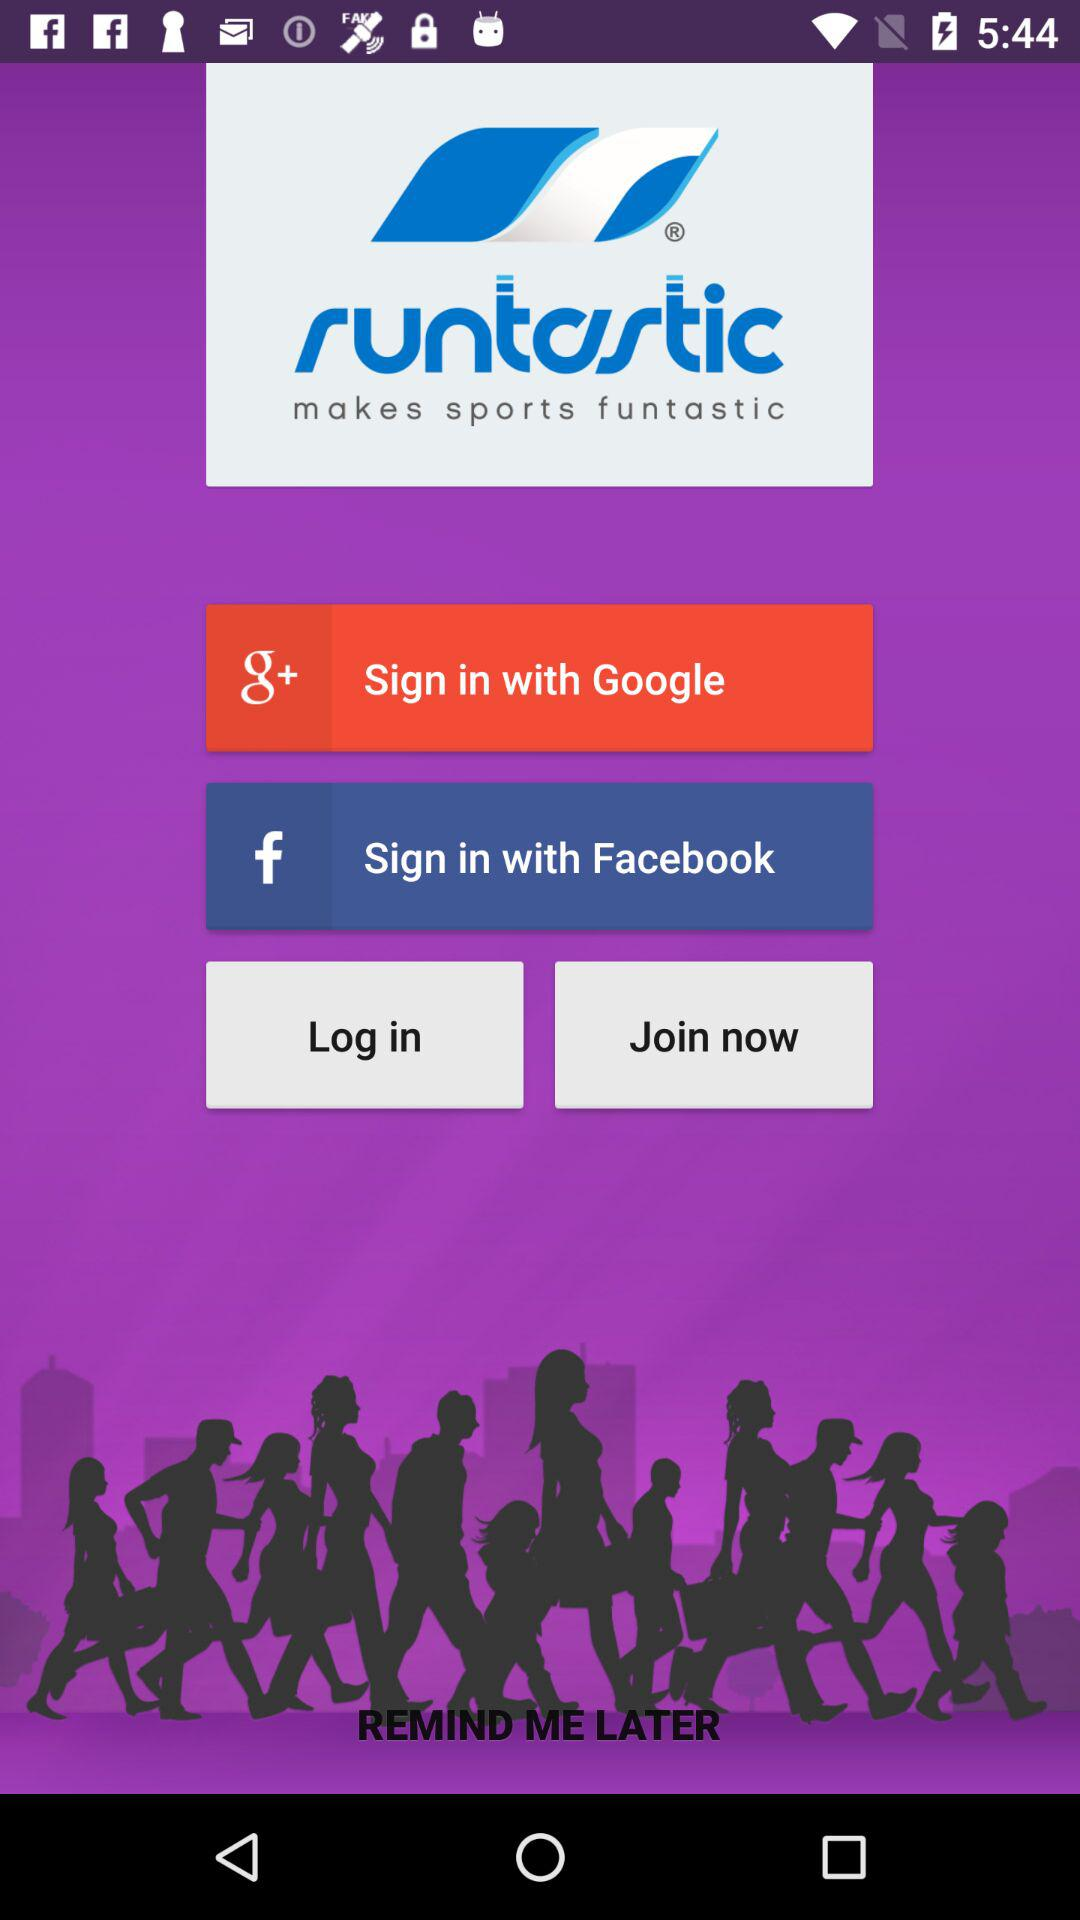Through which accounts can sign in be done? You can sign in with "Google" and "Facebook". 